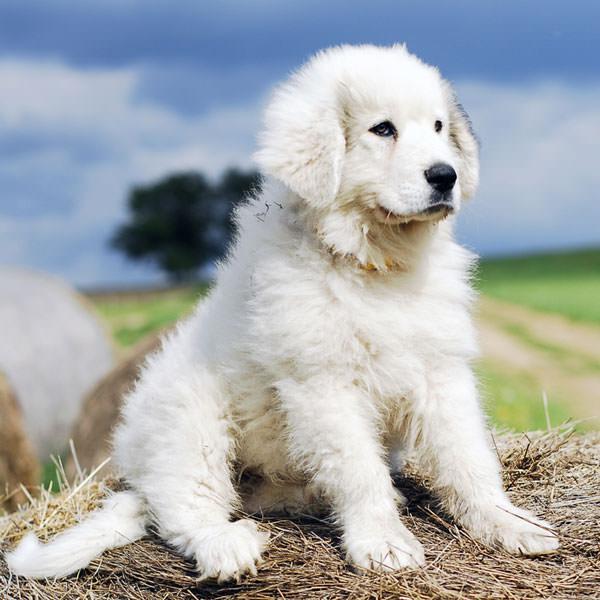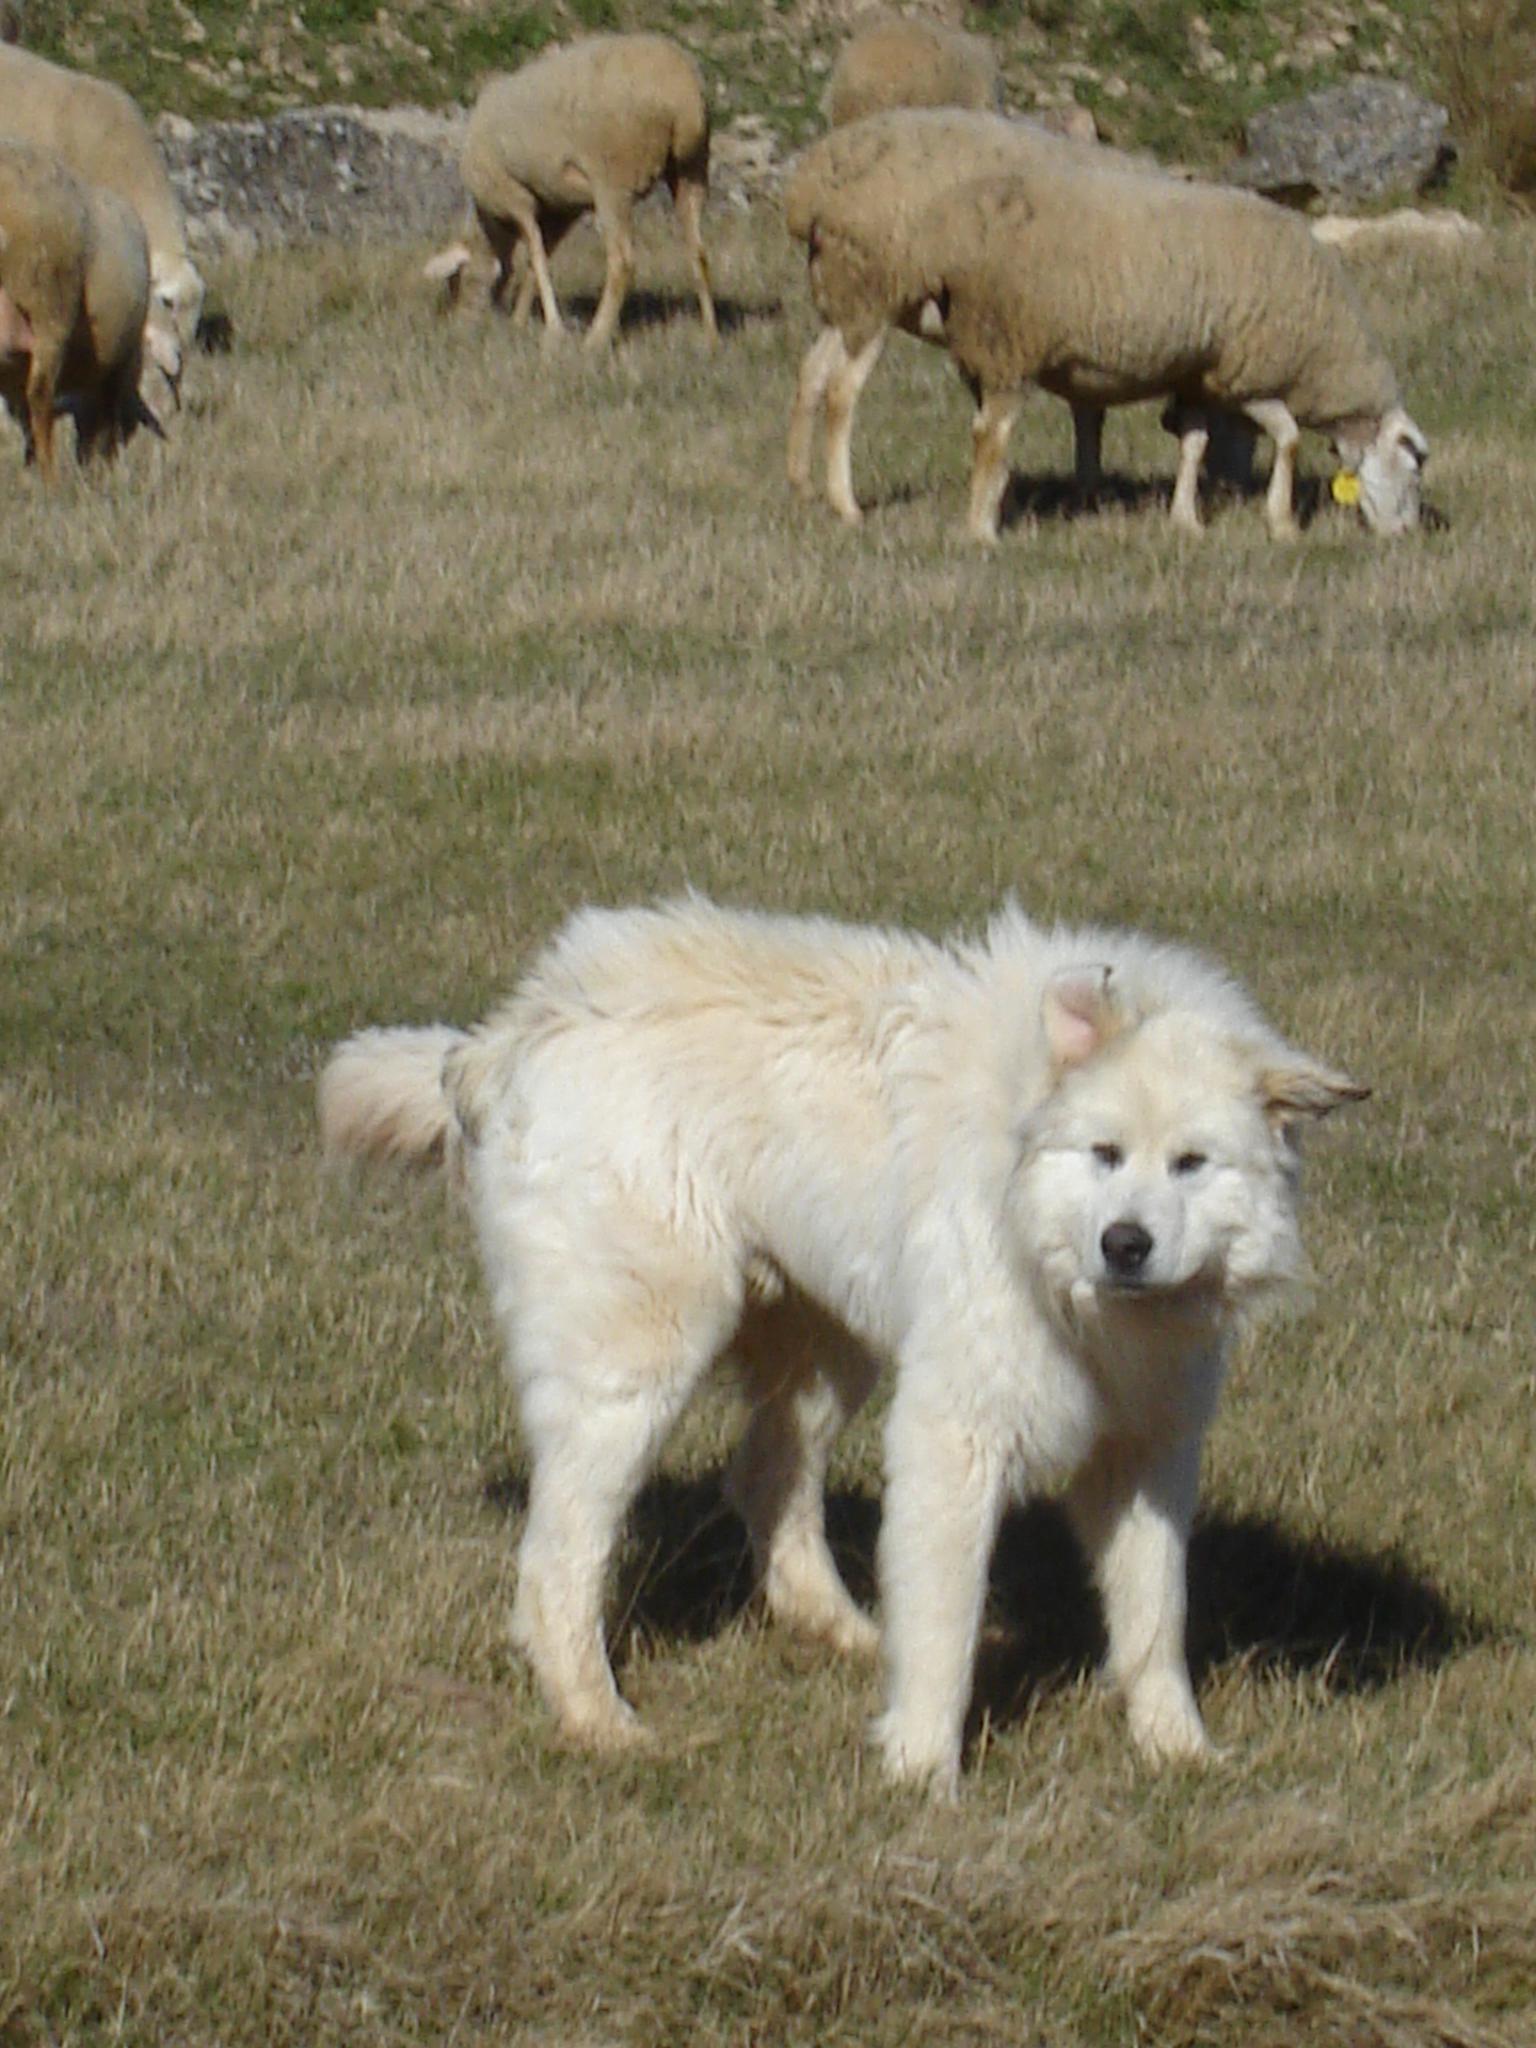The first image is the image on the left, the second image is the image on the right. Given the left and right images, does the statement "A white furry dog is in front of a group of sheep." hold true? Answer yes or no. Yes. The first image is the image on the left, the second image is the image on the right. Considering the images on both sides, is "There are more animals in the image on the right." valid? Answer yes or no. Yes. 